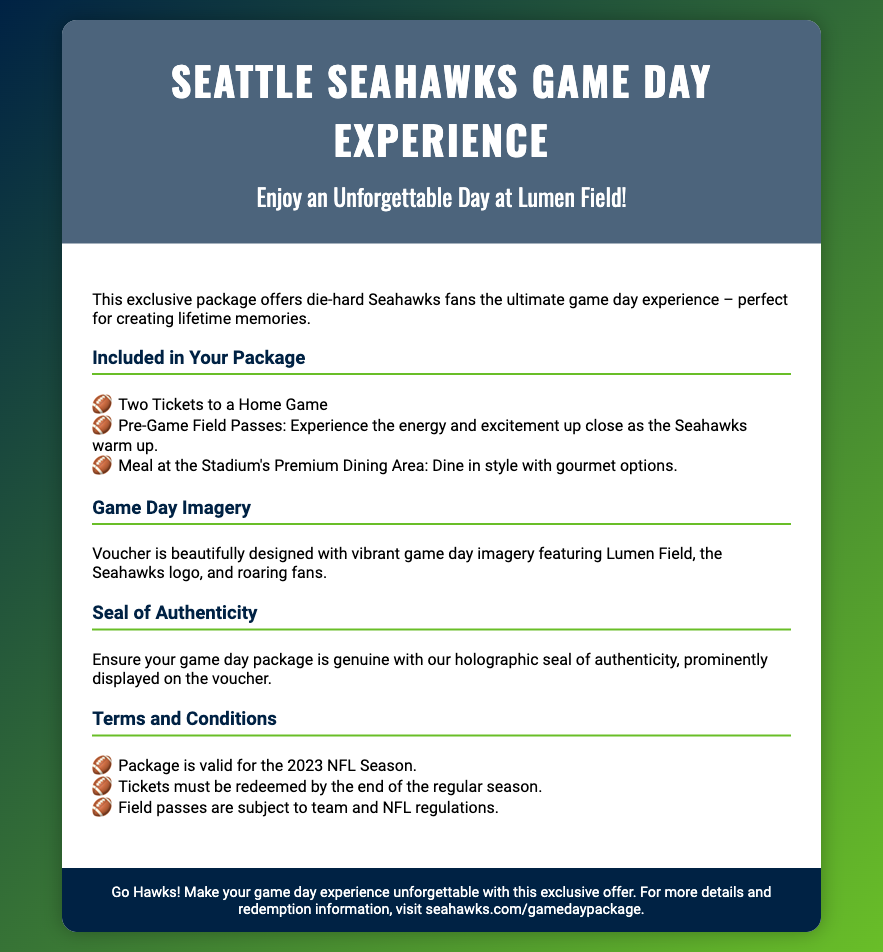What is the package title? The title of the package is prominently displayed at the top of the document.
Answer: Seattle Seahawks Game Day Experience How many tickets are included? The number of tickets is listed in the "Included in Your Package" section.
Answer: Two Tickets What type of meal is provided? The meal information is found in the package details under "Included in Your Package."
Answer: Gourmet options What season is the package valid for? The validity of the package is mentioned in the "Terms and Conditions" section.
Answer: 2023 NFL Season What is used to confirm the voucher's authenticity? The document mentions a specific feature that ensures the package is genuine.
Answer: Holographic seal What major event do the field passes allow access to? The specific experience related to the field passes is mentioned in the package details.
Answer: Pre-Game Warm Ups What is the design theme of the voucher? The theme is described in the "Game Day Imagery" section.
Answer: Vibrant game day imagery What is highlighted in the footer? The footer provides a call to action and sentiment regarding the offer.
Answer: Go Hawks! 